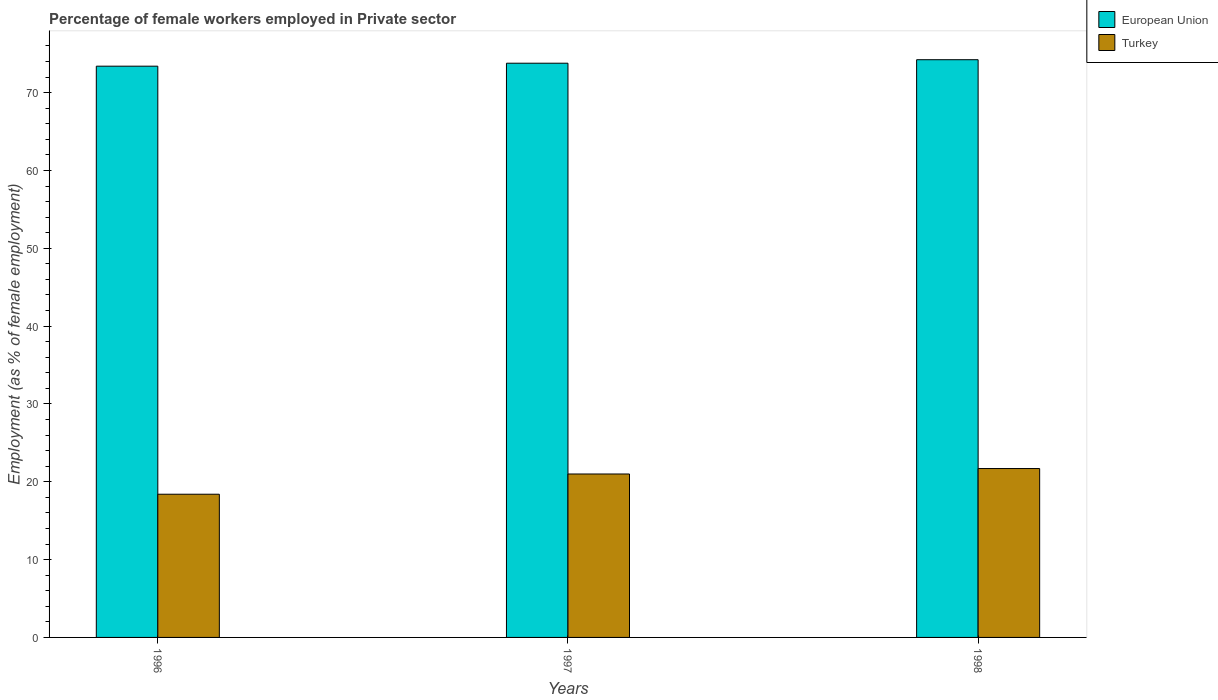How many groups of bars are there?
Ensure brevity in your answer.  3. Are the number of bars per tick equal to the number of legend labels?
Ensure brevity in your answer.  Yes. Are the number of bars on each tick of the X-axis equal?
Ensure brevity in your answer.  Yes. How many bars are there on the 3rd tick from the left?
Your response must be concise. 2. What is the label of the 3rd group of bars from the left?
Your answer should be very brief. 1998. What is the percentage of females employed in Private sector in European Union in 1997?
Keep it short and to the point. 73.78. Across all years, what is the maximum percentage of females employed in Private sector in Turkey?
Offer a terse response. 21.7. Across all years, what is the minimum percentage of females employed in Private sector in European Union?
Ensure brevity in your answer.  73.4. In which year was the percentage of females employed in Private sector in European Union minimum?
Make the answer very short. 1996. What is the total percentage of females employed in Private sector in Turkey in the graph?
Offer a very short reply. 61.1. What is the difference between the percentage of females employed in Private sector in European Union in 1997 and that in 1998?
Offer a terse response. -0.45. What is the difference between the percentage of females employed in Private sector in European Union in 1998 and the percentage of females employed in Private sector in Turkey in 1996?
Make the answer very short. 55.83. What is the average percentage of females employed in Private sector in Turkey per year?
Provide a succinct answer. 20.37. In the year 1996, what is the difference between the percentage of females employed in Private sector in Turkey and percentage of females employed in Private sector in European Union?
Your response must be concise. -55. In how many years, is the percentage of females employed in Private sector in European Union greater than 24 %?
Your answer should be very brief. 3. What is the ratio of the percentage of females employed in Private sector in European Union in 1997 to that in 1998?
Make the answer very short. 0.99. Is the percentage of females employed in Private sector in European Union in 1996 less than that in 1997?
Provide a succinct answer. Yes. What is the difference between the highest and the second highest percentage of females employed in Private sector in European Union?
Your answer should be compact. 0.45. What is the difference between the highest and the lowest percentage of females employed in Private sector in Turkey?
Your answer should be compact. 3.3. Is the sum of the percentage of females employed in Private sector in Turkey in 1996 and 1997 greater than the maximum percentage of females employed in Private sector in European Union across all years?
Ensure brevity in your answer.  No. What does the 2nd bar from the left in 1996 represents?
Provide a short and direct response. Turkey. What does the 1st bar from the right in 1997 represents?
Your answer should be very brief. Turkey. How many bars are there?
Your answer should be very brief. 6. How many years are there in the graph?
Make the answer very short. 3. Does the graph contain grids?
Provide a succinct answer. No. How are the legend labels stacked?
Your answer should be very brief. Vertical. What is the title of the graph?
Your response must be concise. Percentage of female workers employed in Private sector. Does "Slovak Republic" appear as one of the legend labels in the graph?
Provide a short and direct response. No. What is the label or title of the X-axis?
Your answer should be compact. Years. What is the label or title of the Y-axis?
Offer a very short reply. Employment (as % of female employment). What is the Employment (as % of female employment) in European Union in 1996?
Offer a very short reply. 73.4. What is the Employment (as % of female employment) of Turkey in 1996?
Provide a succinct answer. 18.4. What is the Employment (as % of female employment) in European Union in 1997?
Keep it short and to the point. 73.78. What is the Employment (as % of female employment) in Turkey in 1997?
Your response must be concise. 21. What is the Employment (as % of female employment) of European Union in 1998?
Your answer should be compact. 74.23. What is the Employment (as % of female employment) of Turkey in 1998?
Your response must be concise. 21.7. Across all years, what is the maximum Employment (as % of female employment) in European Union?
Keep it short and to the point. 74.23. Across all years, what is the maximum Employment (as % of female employment) in Turkey?
Provide a succinct answer. 21.7. Across all years, what is the minimum Employment (as % of female employment) in European Union?
Ensure brevity in your answer.  73.4. Across all years, what is the minimum Employment (as % of female employment) of Turkey?
Make the answer very short. 18.4. What is the total Employment (as % of female employment) of European Union in the graph?
Offer a terse response. 221.41. What is the total Employment (as % of female employment) of Turkey in the graph?
Provide a short and direct response. 61.1. What is the difference between the Employment (as % of female employment) in European Union in 1996 and that in 1997?
Provide a succinct answer. -0.38. What is the difference between the Employment (as % of female employment) of European Union in 1996 and that in 1998?
Offer a very short reply. -0.83. What is the difference between the Employment (as % of female employment) of Turkey in 1996 and that in 1998?
Make the answer very short. -3.3. What is the difference between the Employment (as % of female employment) in European Union in 1997 and that in 1998?
Provide a short and direct response. -0.45. What is the difference between the Employment (as % of female employment) in Turkey in 1997 and that in 1998?
Make the answer very short. -0.7. What is the difference between the Employment (as % of female employment) of European Union in 1996 and the Employment (as % of female employment) of Turkey in 1997?
Provide a succinct answer. 52.4. What is the difference between the Employment (as % of female employment) of European Union in 1996 and the Employment (as % of female employment) of Turkey in 1998?
Your answer should be compact. 51.7. What is the difference between the Employment (as % of female employment) of European Union in 1997 and the Employment (as % of female employment) of Turkey in 1998?
Your answer should be compact. 52.08. What is the average Employment (as % of female employment) in European Union per year?
Offer a terse response. 73.8. What is the average Employment (as % of female employment) of Turkey per year?
Provide a short and direct response. 20.37. In the year 1996, what is the difference between the Employment (as % of female employment) of European Union and Employment (as % of female employment) of Turkey?
Keep it short and to the point. 55. In the year 1997, what is the difference between the Employment (as % of female employment) of European Union and Employment (as % of female employment) of Turkey?
Provide a short and direct response. 52.78. In the year 1998, what is the difference between the Employment (as % of female employment) of European Union and Employment (as % of female employment) of Turkey?
Offer a very short reply. 52.53. What is the ratio of the Employment (as % of female employment) of European Union in 1996 to that in 1997?
Your answer should be very brief. 0.99. What is the ratio of the Employment (as % of female employment) of Turkey in 1996 to that in 1997?
Your answer should be compact. 0.88. What is the ratio of the Employment (as % of female employment) of Turkey in 1996 to that in 1998?
Your response must be concise. 0.85. What is the ratio of the Employment (as % of female employment) in European Union in 1997 to that in 1998?
Offer a terse response. 0.99. What is the ratio of the Employment (as % of female employment) of Turkey in 1997 to that in 1998?
Give a very brief answer. 0.97. What is the difference between the highest and the second highest Employment (as % of female employment) in European Union?
Ensure brevity in your answer.  0.45. What is the difference between the highest and the lowest Employment (as % of female employment) of European Union?
Offer a very short reply. 0.83. What is the difference between the highest and the lowest Employment (as % of female employment) of Turkey?
Offer a terse response. 3.3. 